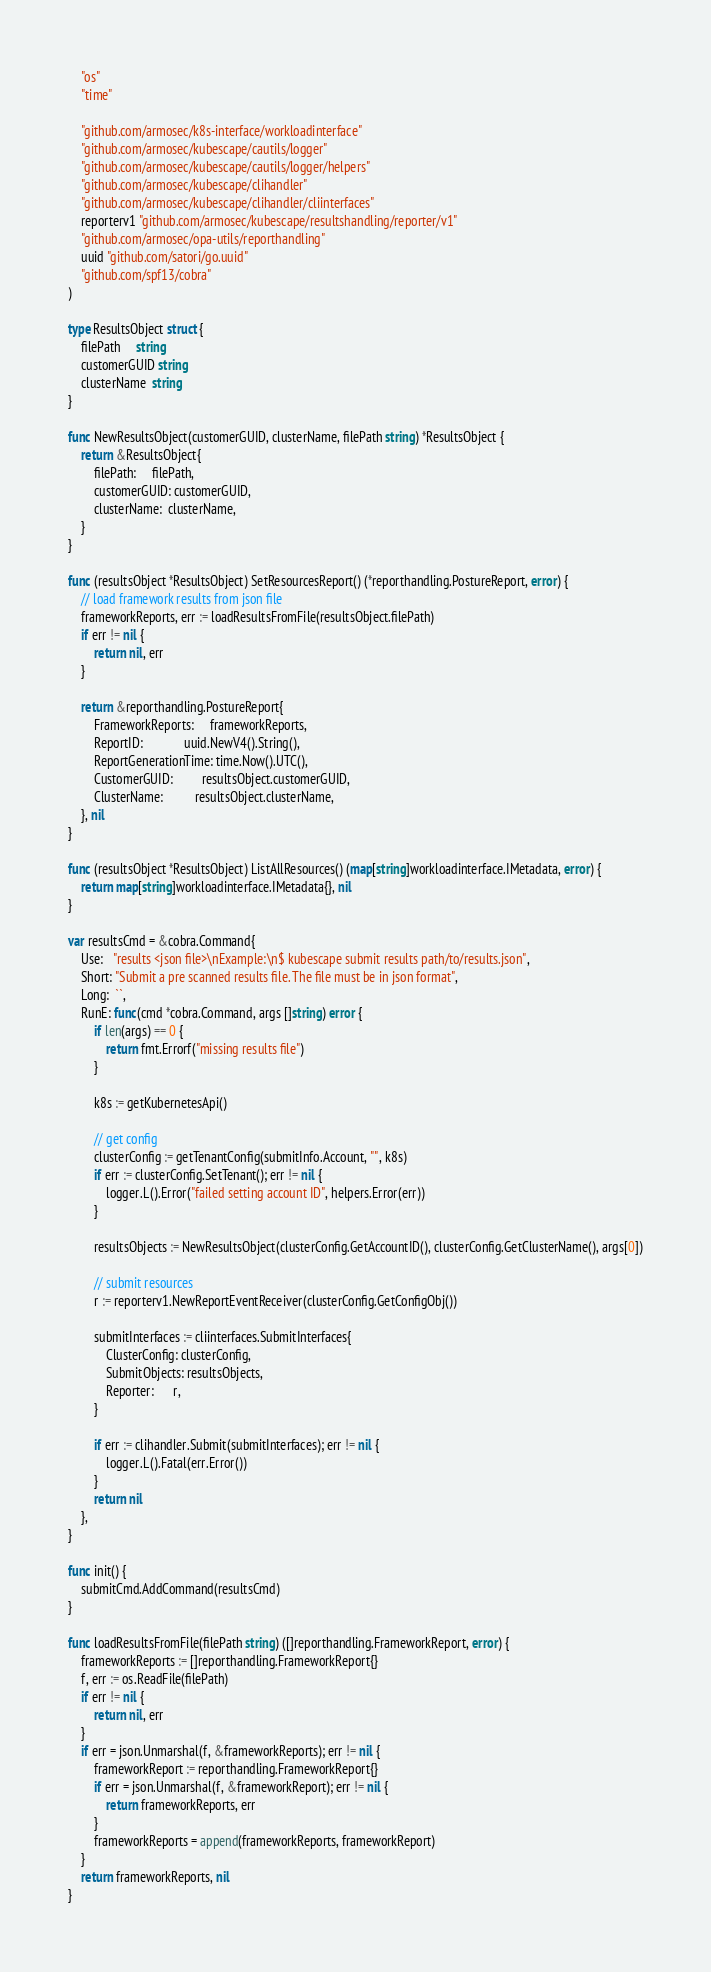Convert code to text. <code><loc_0><loc_0><loc_500><loc_500><_Go_>	"os"
	"time"

	"github.com/armosec/k8s-interface/workloadinterface"
	"github.com/armosec/kubescape/cautils/logger"
	"github.com/armosec/kubescape/cautils/logger/helpers"
	"github.com/armosec/kubescape/clihandler"
	"github.com/armosec/kubescape/clihandler/cliinterfaces"
	reporterv1 "github.com/armosec/kubescape/resultshandling/reporter/v1"
	"github.com/armosec/opa-utils/reporthandling"
	uuid "github.com/satori/go.uuid"
	"github.com/spf13/cobra"
)

type ResultsObject struct {
	filePath     string
	customerGUID string
	clusterName  string
}

func NewResultsObject(customerGUID, clusterName, filePath string) *ResultsObject {
	return &ResultsObject{
		filePath:     filePath,
		customerGUID: customerGUID,
		clusterName:  clusterName,
	}
}

func (resultsObject *ResultsObject) SetResourcesReport() (*reporthandling.PostureReport, error) {
	// load framework results from json file
	frameworkReports, err := loadResultsFromFile(resultsObject.filePath)
	if err != nil {
		return nil, err
	}

	return &reporthandling.PostureReport{
		FrameworkReports:     frameworkReports,
		ReportID:             uuid.NewV4().String(),
		ReportGenerationTime: time.Now().UTC(),
		CustomerGUID:         resultsObject.customerGUID,
		ClusterName:          resultsObject.clusterName,
	}, nil
}

func (resultsObject *ResultsObject) ListAllResources() (map[string]workloadinterface.IMetadata, error) {
	return map[string]workloadinterface.IMetadata{}, nil
}

var resultsCmd = &cobra.Command{
	Use:   "results <json file>\nExample:\n$ kubescape submit results path/to/results.json",
	Short: "Submit a pre scanned results file. The file must be in json format",
	Long:  ``,
	RunE: func(cmd *cobra.Command, args []string) error {
		if len(args) == 0 {
			return fmt.Errorf("missing results file")
		}

		k8s := getKubernetesApi()

		// get config
		clusterConfig := getTenantConfig(submitInfo.Account, "", k8s)
		if err := clusterConfig.SetTenant(); err != nil {
			logger.L().Error("failed setting account ID", helpers.Error(err))
		}

		resultsObjects := NewResultsObject(clusterConfig.GetAccountID(), clusterConfig.GetClusterName(), args[0])

		// submit resources
		r := reporterv1.NewReportEventReceiver(clusterConfig.GetConfigObj())

		submitInterfaces := cliinterfaces.SubmitInterfaces{
			ClusterConfig: clusterConfig,
			SubmitObjects: resultsObjects,
			Reporter:      r,
		}

		if err := clihandler.Submit(submitInterfaces); err != nil {
			logger.L().Fatal(err.Error())
		}
		return nil
	},
}

func init() {
	submitCmd.AddCommand(resultsCmd)
}

func loadResultsFromFile(filePath string) ([]reporthandling.FrameworkReport, error) {
	frameworkReports := []reporthandling.FrameworkReport{}
	f, err := os.ReadFile(filePath)
	if err != nil {
		return nil, err
	}
	if err = json.Unmarshal(f, &frameworkReports); err != nil {
		frameworkReport := reporthandling.FrameworkReport{}
		if err = json.Unmarshal(f, &frameworkReport); err != nil {
			return frameworkReports, err
		}
		frameworkReports = append(frameworkReports, frameworkReport)
	}
	return frameworkReports, nil
}
</code> 